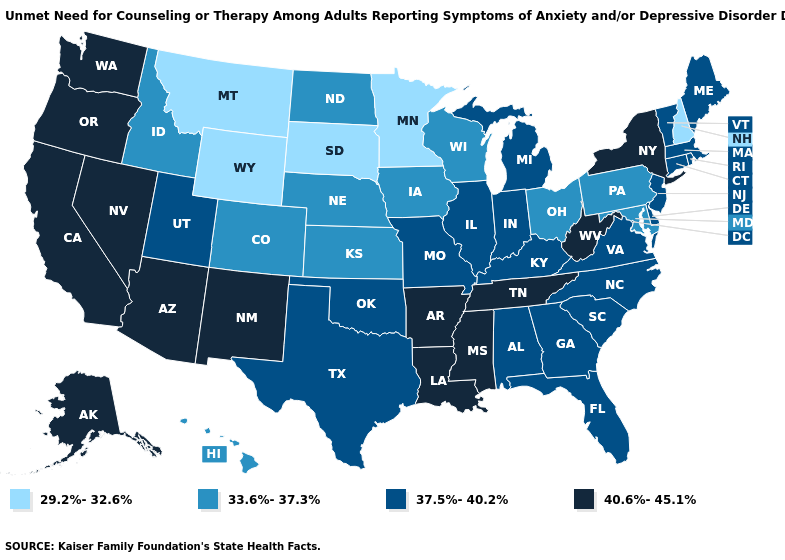Which states have the highest value in the USA?
Concise answer only. Alaska, Arizona, Arkansas, California, Louisiana, Mississippi, Nevada, New Mexico, New York, Oregon, Tennessee, Washington, West Virginia. Does Tennessee have a higher value than Mississippi?
Answer briefly. No. What is the lowest value in the MidWest?
Short answer required. 29.2%-32.6%. What is the highest value in the USA?
Be succinct. 40.6%-45.1%. Which states have the highest value in the USA?
Write a very short answer. Alaska, Arizona, Arkansas, California, Louisiana, Mississippi, Nevada, New Mexico, New York, Oregon, Tennessee, Washington, West Virginia. Among the states that border Louisiana , does Arkansas have the highest value?
Quick response, please. Yes. What is the highest value in states that border Kentucky?
Write a very short answer. 40.6%-45.1%. Does the map have missing data?
Short answer required. No. Name the states that have a value in the range 29.2%-32.6%?
Give a very brief answer. Minnesota, Montana, New Hampshire, South Dakota, Wyoming. What is the lowest value in the Northeast?
Give a very brief answer. 29.2%-32.6%. What is the value of Nebraska?
Answer briefly. 33.6%-37.3%. Name the states that have a value in the range 33.6%-37.3%?
Concise answer only. Colorado, Hawaii, Idaho, Iowa, Kansas, Maryland, Nebraska, North Dakota, Ohio, Pennsylvania, Wisconsin. What is the highest value in the USA?
Answer briefly. 40.6%-45.1%. Name the states that have a value in the range 37.5%-40.2%?
Quick response, please. Alabama, Connecticut, Delaware, Florida, Georgia, Illinois, Indiana, Kentucky, Maine, Massachusetts, Michigan, Missouri, New Jersey, North Carolina, Oklahoma, Rhode Island, South Carolina, Texas, Utah, Vermont, Virginia. 